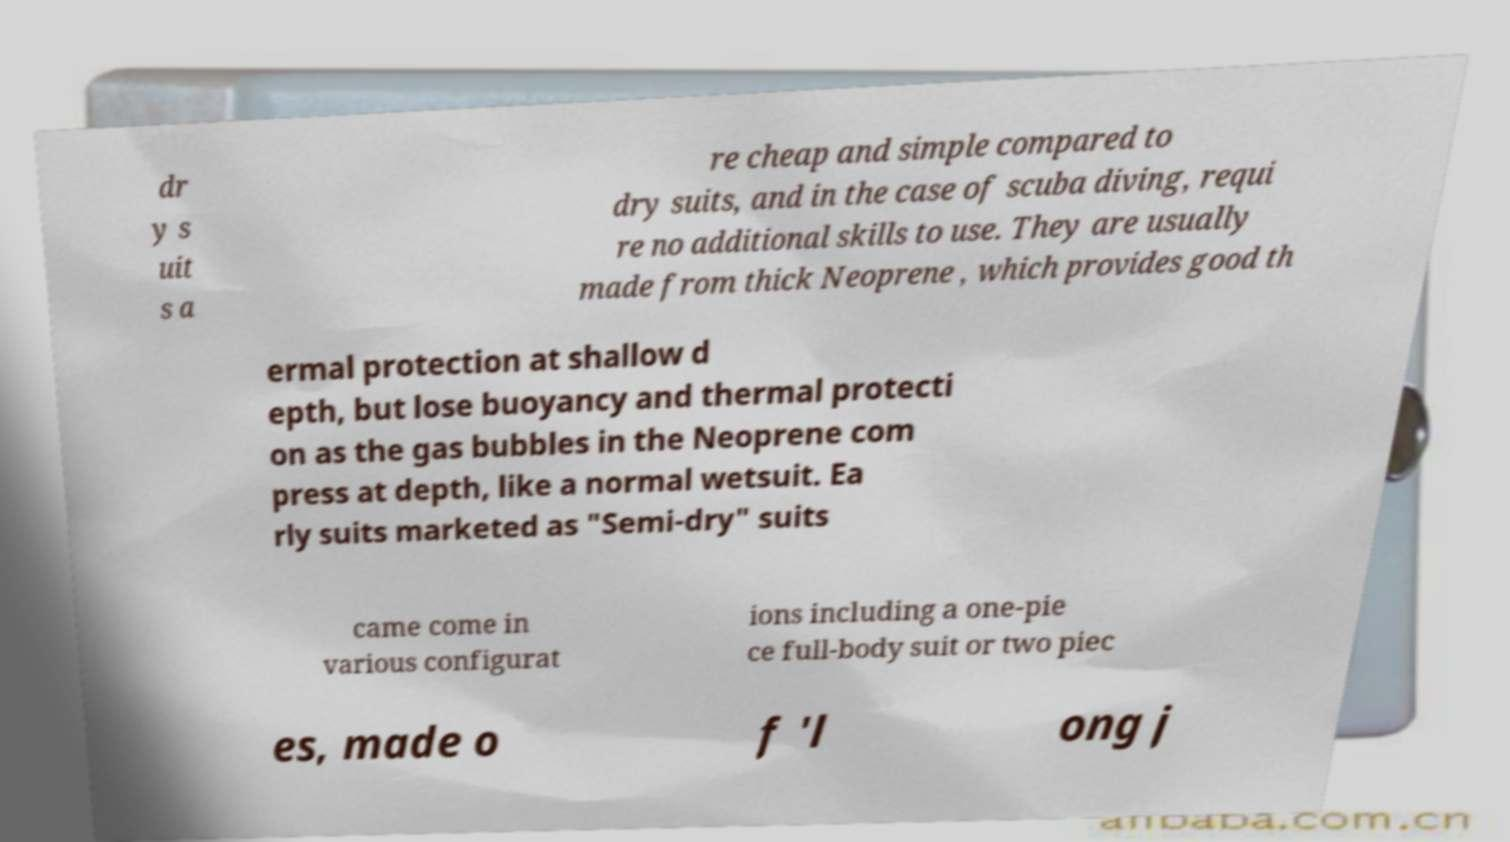Could you extract and type out the text from this image? dr y s uit s a re cheap and simple compared to dry suits, and in the case of scuba diving, requi re no additional skills to use. They are usually made from thick Neoprene , which provides good th ermal protection at shallow d epth, but lose buoyancy and thermal protecti on as the gas bubbles in the Neoprene com press at depth, like a normal wetsuit. Ea rly suits marketed as "Semi-dry" suits came come in various configurat ions including a one-pie ce full-body suit or two piec es, made o f 'l ong j 